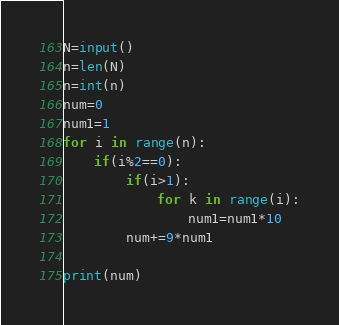<code> <loc_0><loc_0><loc_500><loc_500><_Python_>N=input()
n=len(N)
n=int(n)
num=0
num1=1
for i in range(n):
    if(i%2==0):
        if(i>1):
            for k in range(i):
                num1=num1*10
        num+=9*num1

print(num)
</code> 